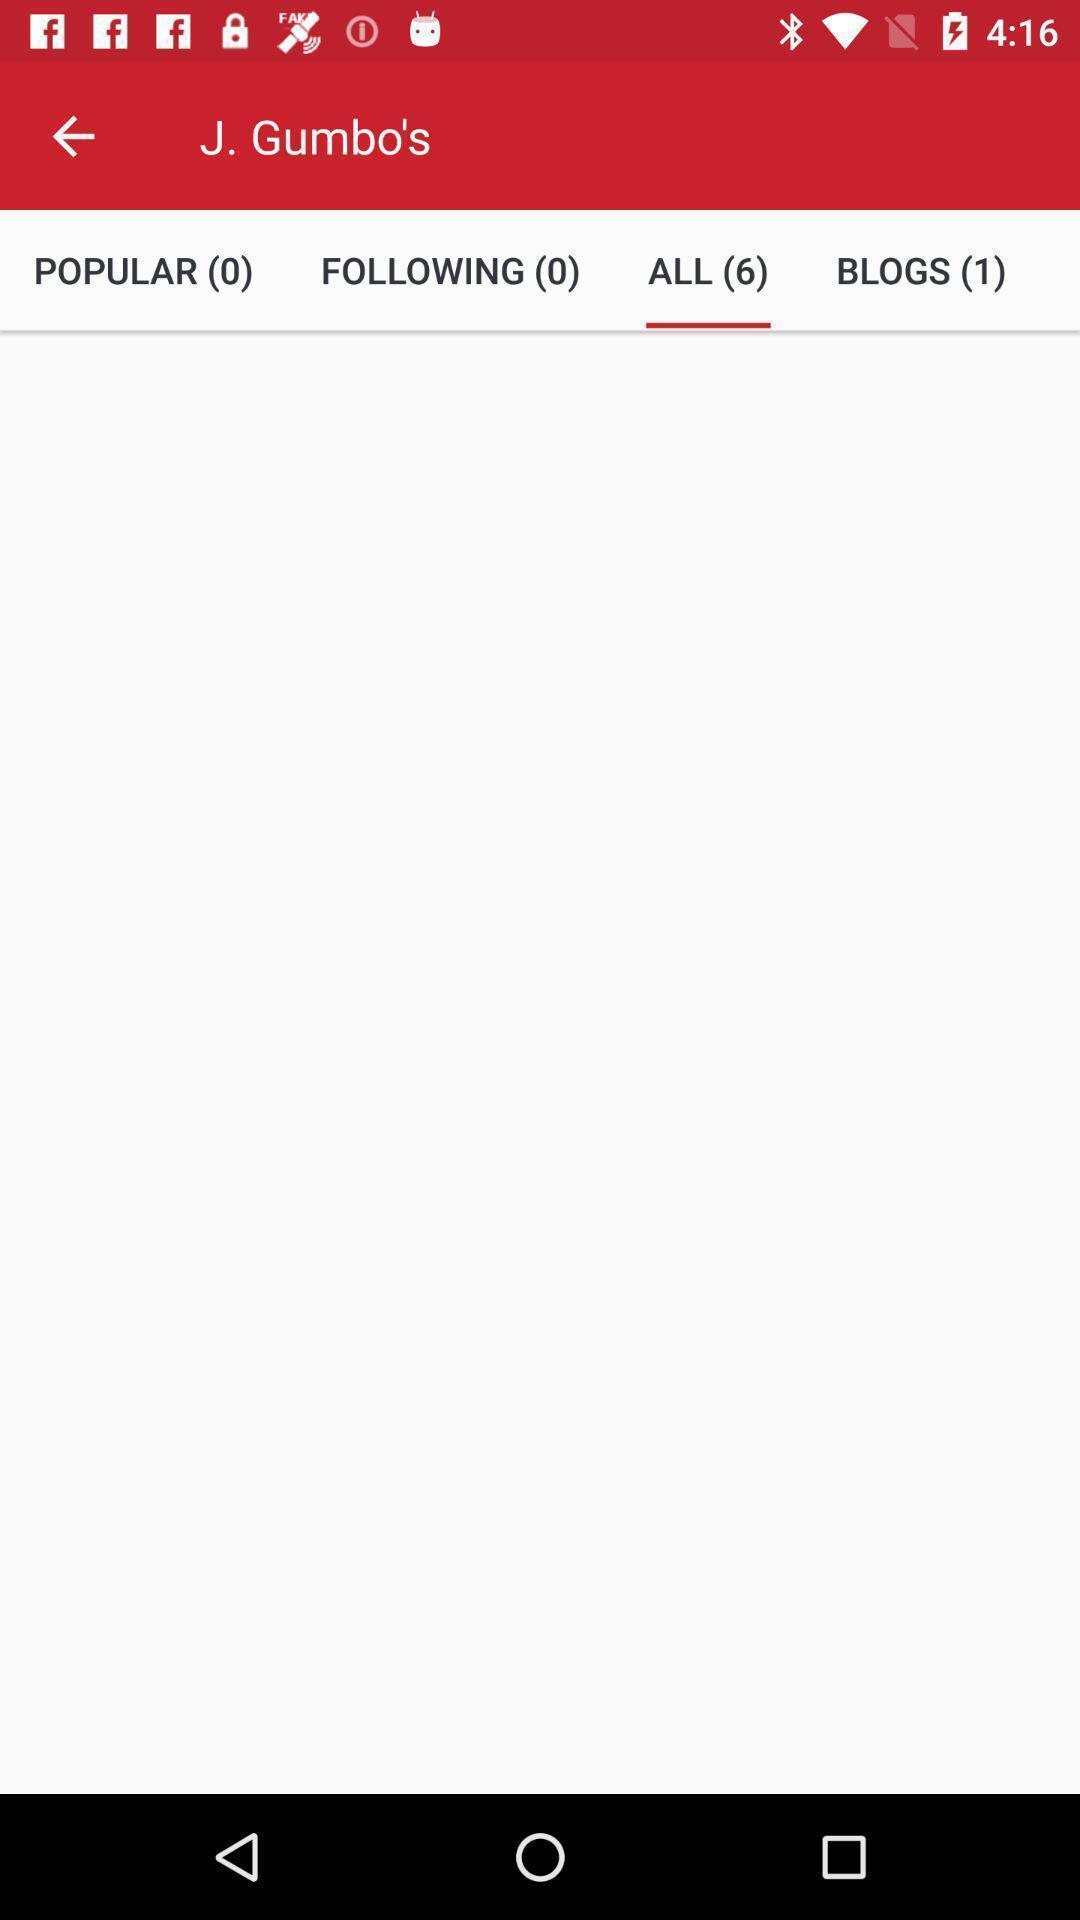Describe the content in this image. Screen shows to browse through restaurant menus. 